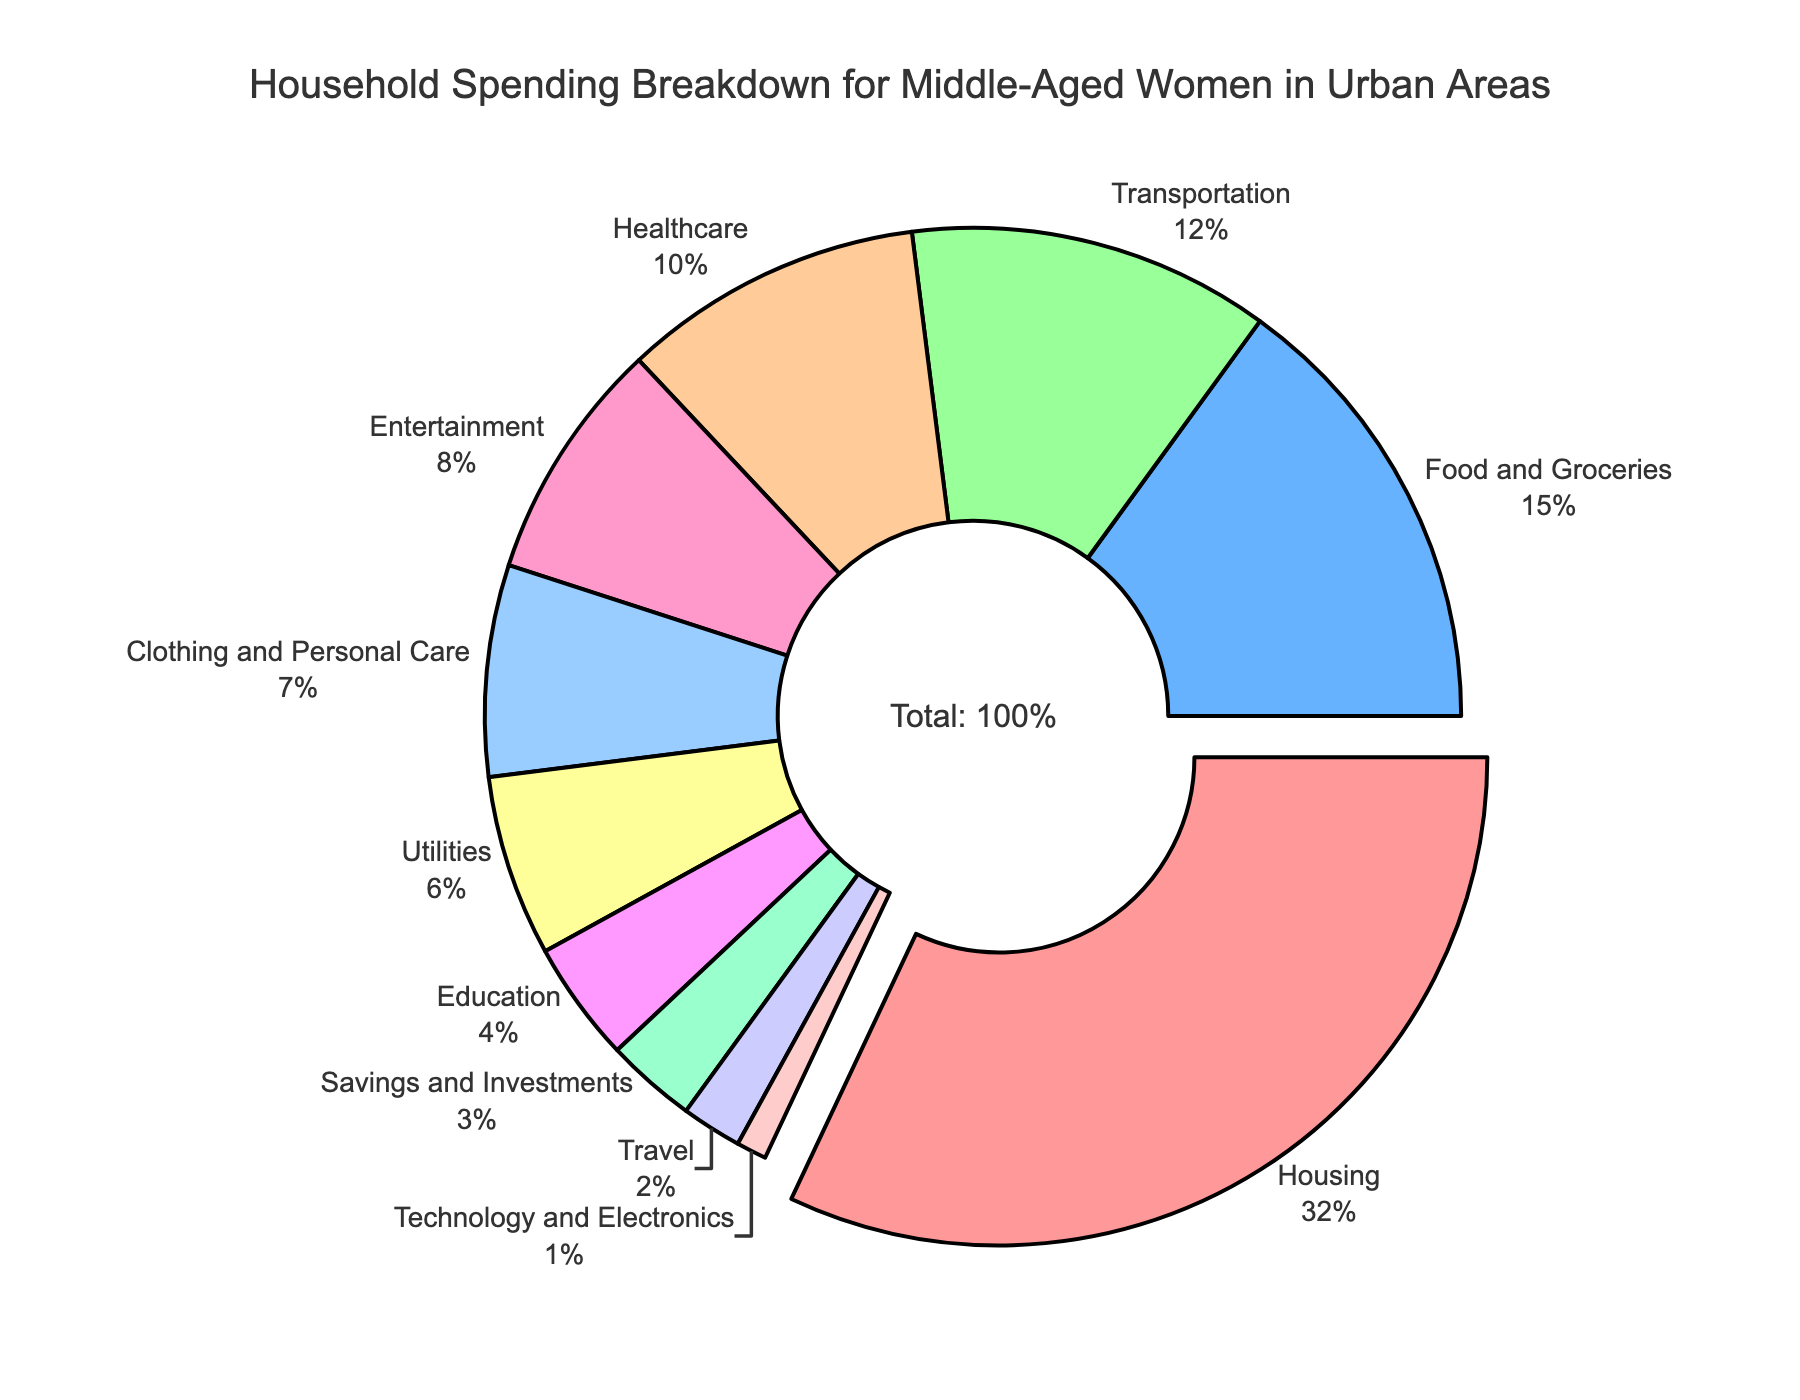Which category has the largest expenditure? The largest expenditure can be identified by looking at the segment of the pie chart that is pulled out. The segment for Housing is pulled out, indicating that it is the largest category with a percentage of 32%.
Answer: Housing Which two categories combined make up nearly half of the total expenditures? By visual inspection, the categories Housing (32%) and Food and Groceries (15%) are the largest. Adding their percentages: 32% + 15% = 47%, which is nearly half of the total expenditures.
Answer: Housing and Food and Groceries How much more is spent on Transportation compared to Technology and Electronics? Looking at the pie chart: Transportation has 12% and Technology and Electronics has 1%. The difference is 12% - 1% = 11%.
Answer: 11% Which category has the smallest expenditure, and what is its percentage? The smallest segment in the pie chart represents the category Technology and Electronics, which has a percentage of 1%.
Answer: Technology and Electronics, 1% What is the combined percentage of spending on Healthcare and Entertainment? Observing the pie chart, Healthcare has 10% and Entertainment has 8%. Adding these percentages: 10% + 8% = 18%.
Answer: 18% Is the expenditure on Clothing and Personal Care greater than on Education? By comparing the values on the pie chart, Clothing and Personal Care is at 7% while Education is at 4%. Therefore, Clothing and Personal Care is greater than Education.
Answer: Yes How does the spending on Utilities compare to the spending on Travel? The pie chart shows that Utilities have 6% and Travel has 2%. Thus, spending on Utilities is greater than spending on Travel.
Answer: Utilities is greater What is the total percentage of discretionary spending (Entertainment and Travel)? From the pie chart, Entertainment is 8% and Travel is 2%. Adding these percentages: 8% + 2% = 10%.
Answer: 10% Which two categories have the same color, and what are those colors? All categories have unique colors in the pie chart. Therefore, there are no two categories with the same color.
Answer: No categories have the same color 